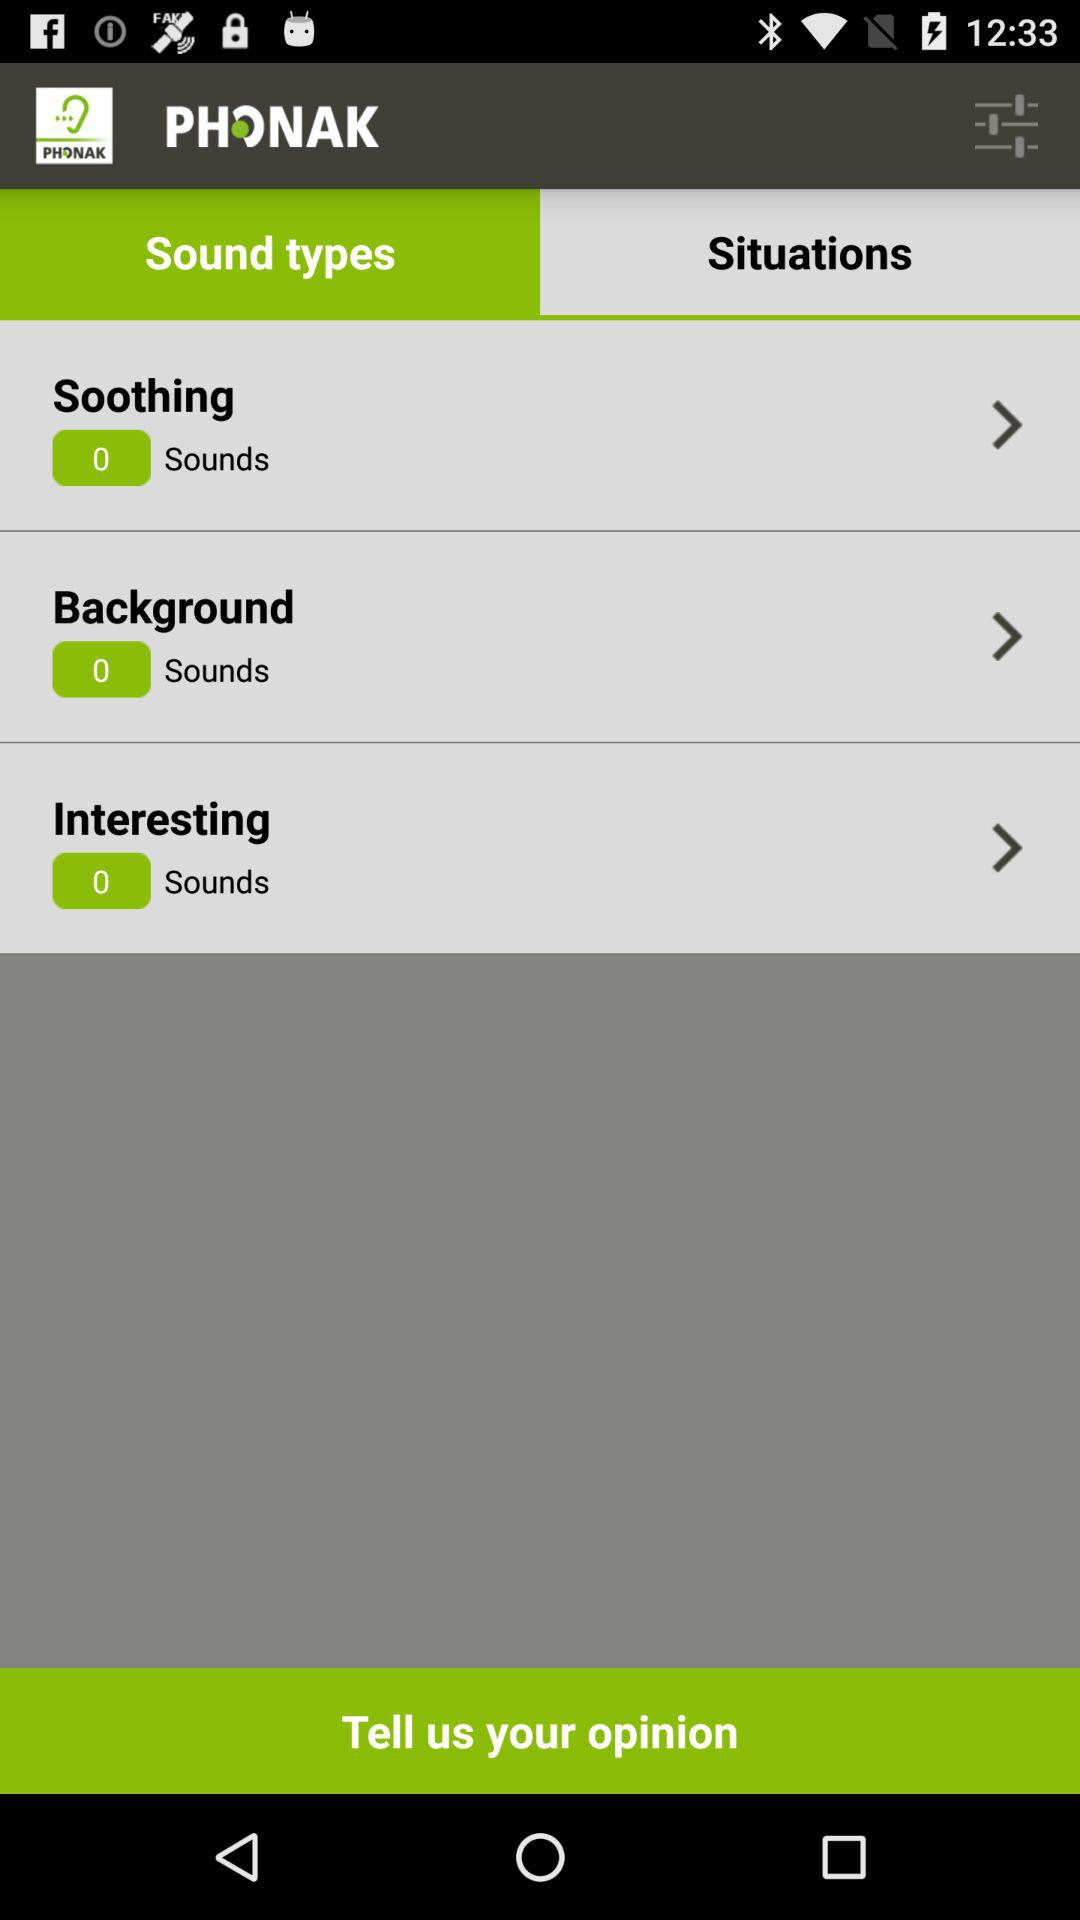Which tab is selected? The selected tab is "Sound types". 